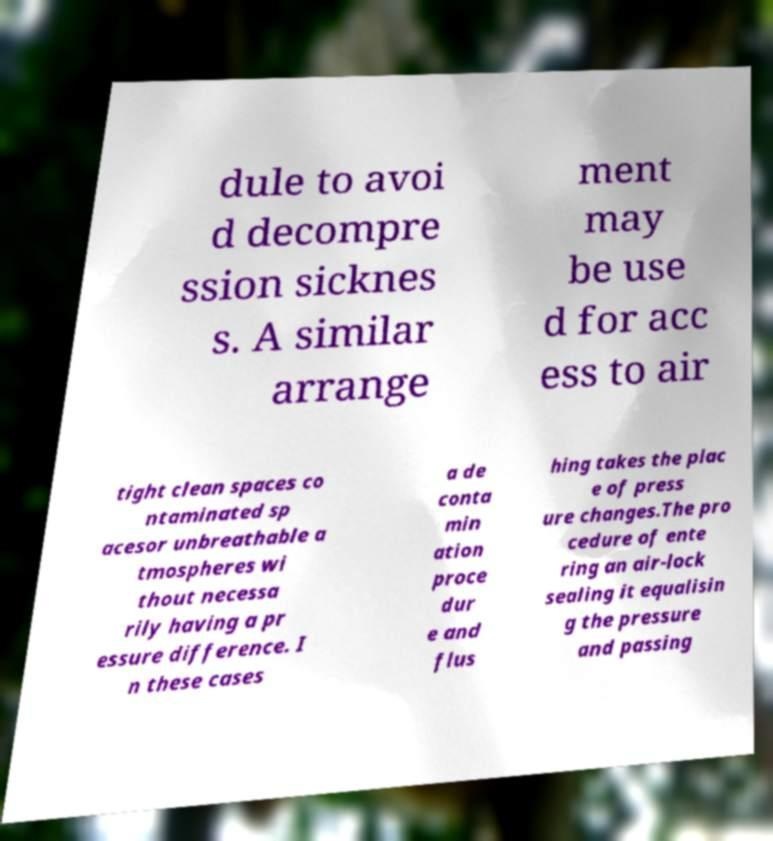What messages or text are displayed in this image? I need them in a readable, typed format. dule to avoi d decompre ssion sicknes s. A similar arrange ment may be use d for acc ess to air tight clean spaces co ntaminated sp acesor unbreathable a tmospheres wi thout necessa rily having a pr essure difference. I n these cases a de conta min ation proce dur e and flus hing takes the plac e of press ure changes.The pro cedure of ente ring an air-lock sealing it equalisin g the pressure and passing 